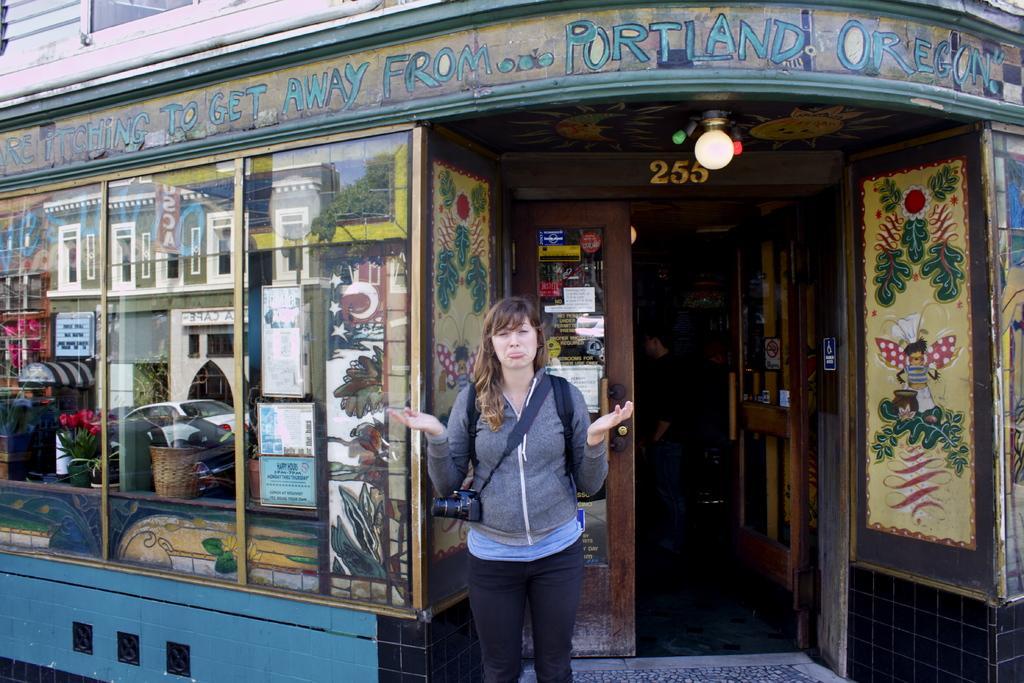How would you summarize this image in a sentence or two? In this image, there is an outside view. There is a person at the bottom of the image standing in front of the building. This person is wearing clothes and camera. 